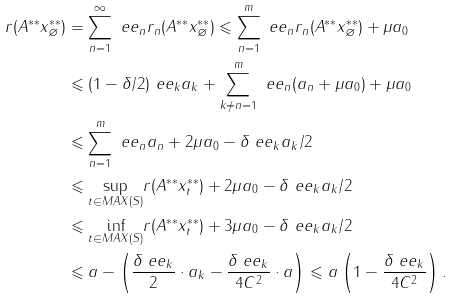<formula> <loc_0><loc_0><loc_500><loc_500>r ( A ^ { * * } x ^ { * * } _ { \varnothing } ) & = \sum _ { n = 1 } ^ { \infty } \ e e _ { n } r _ { n } ( A ^ { * * } x ^ { * * } _ { \varnothing } ) \leqslant \sum _ { n = 1 } ^ { m } \ e e _ { n } r _ { n } ( A ^ { * * } x ^ { * * } _ { \varnothing } ) + \mu a _ { 0 } \\ & \leqslant ( 1 - \delta / 2 ) \ e e _ { k } a _ { k } + \sum _ { k \neq n = 1 } ^ { m } \ e e _ { n } ( a _ { n } + \mu a _ { 0 } ) + \mu a _ { 0 } \\ & \leqslant \sum _ { n = 1 } ^ { m } \ e e _ { n } a _ { n } + 2 \mu a _ { 0 } - \delta \ e e _ { k } a _ { k } / 2 \\ & \leqslant \underset { t \in M A X ( S ) } { \sup } r ( A ^ { * * } x ^ { * * } _ { t } ) + 2 \mu a _ { 0 } - \delta \ e e _ { k } a _ { k } / 2 \\ & \leqslant \underset { t \in M A X ( S ) } { \inf } r ( A ^ { * * } x ^ { * * } _ { t } ) + 3 \mu a _ { 0 } - \delta \ e e _ { k } a _ { k } / 2 \\ & \leqslant a - \left ( \frac { \delta \ e e _ { k } } { 2 } \cdot a _ { k } - \frac { \delta \ e e _ { k } } { 4 C ^ { 2 } } \cdot a \right ) \leqslant a \left ( 1 - \frac { \delta \ e e _ { k } } { 4 C ^ { 2 } } \right ) .</formula> 